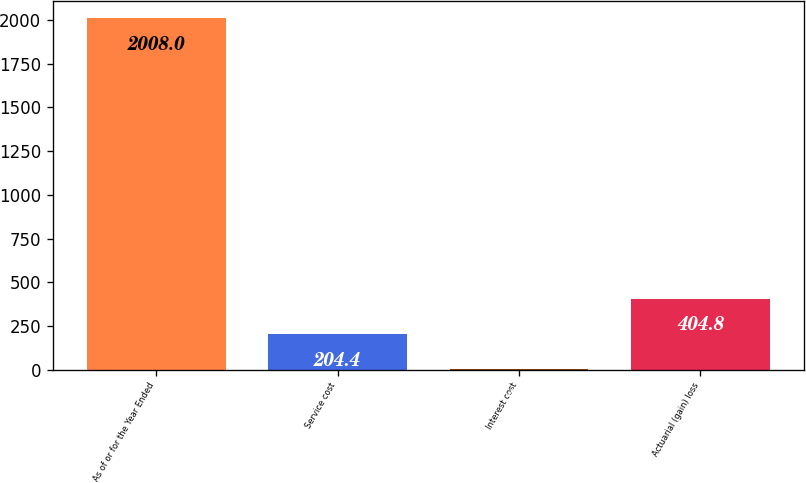<chart> <loc_0><loc_0><loc_500><loc_500><bar_chart><fcel>As of or for the Year Ended<fcel>Service cost<fcel>Interest cost<fcel>Actuarial (gain) loss<nl><fcel>2008<fcel>204.4<fcel>4<fcel>404.8<nl></chart> 